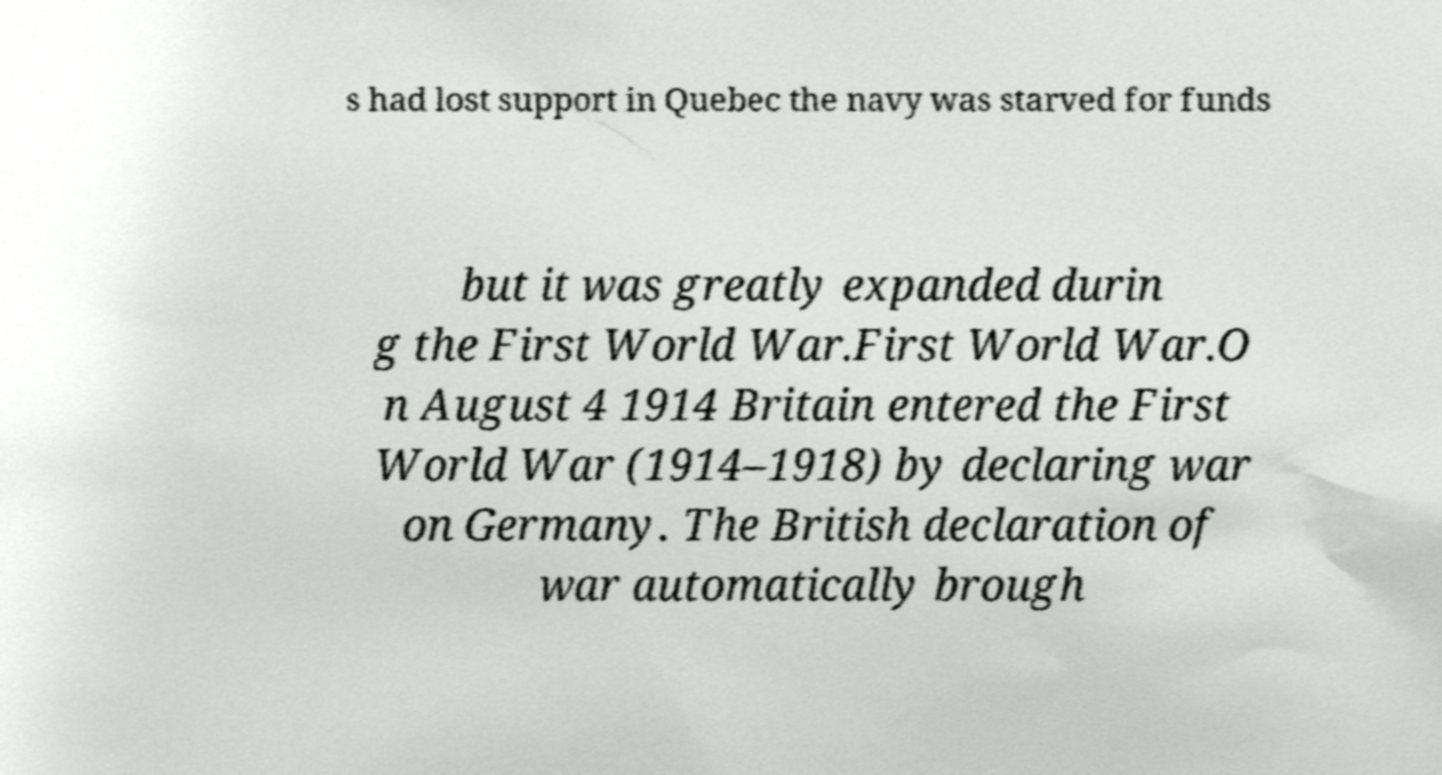For documentation purposes, I need the text within this image transcribed. Could you provide that? s had lost support in Quebec the navy was starved for funds but it was greatly expanded durin g the First World War.First World War.O n August 4 1914 Britain entered the First World War (1914–1918) by declaring war on Germany. The British declaration of war automatically brough 